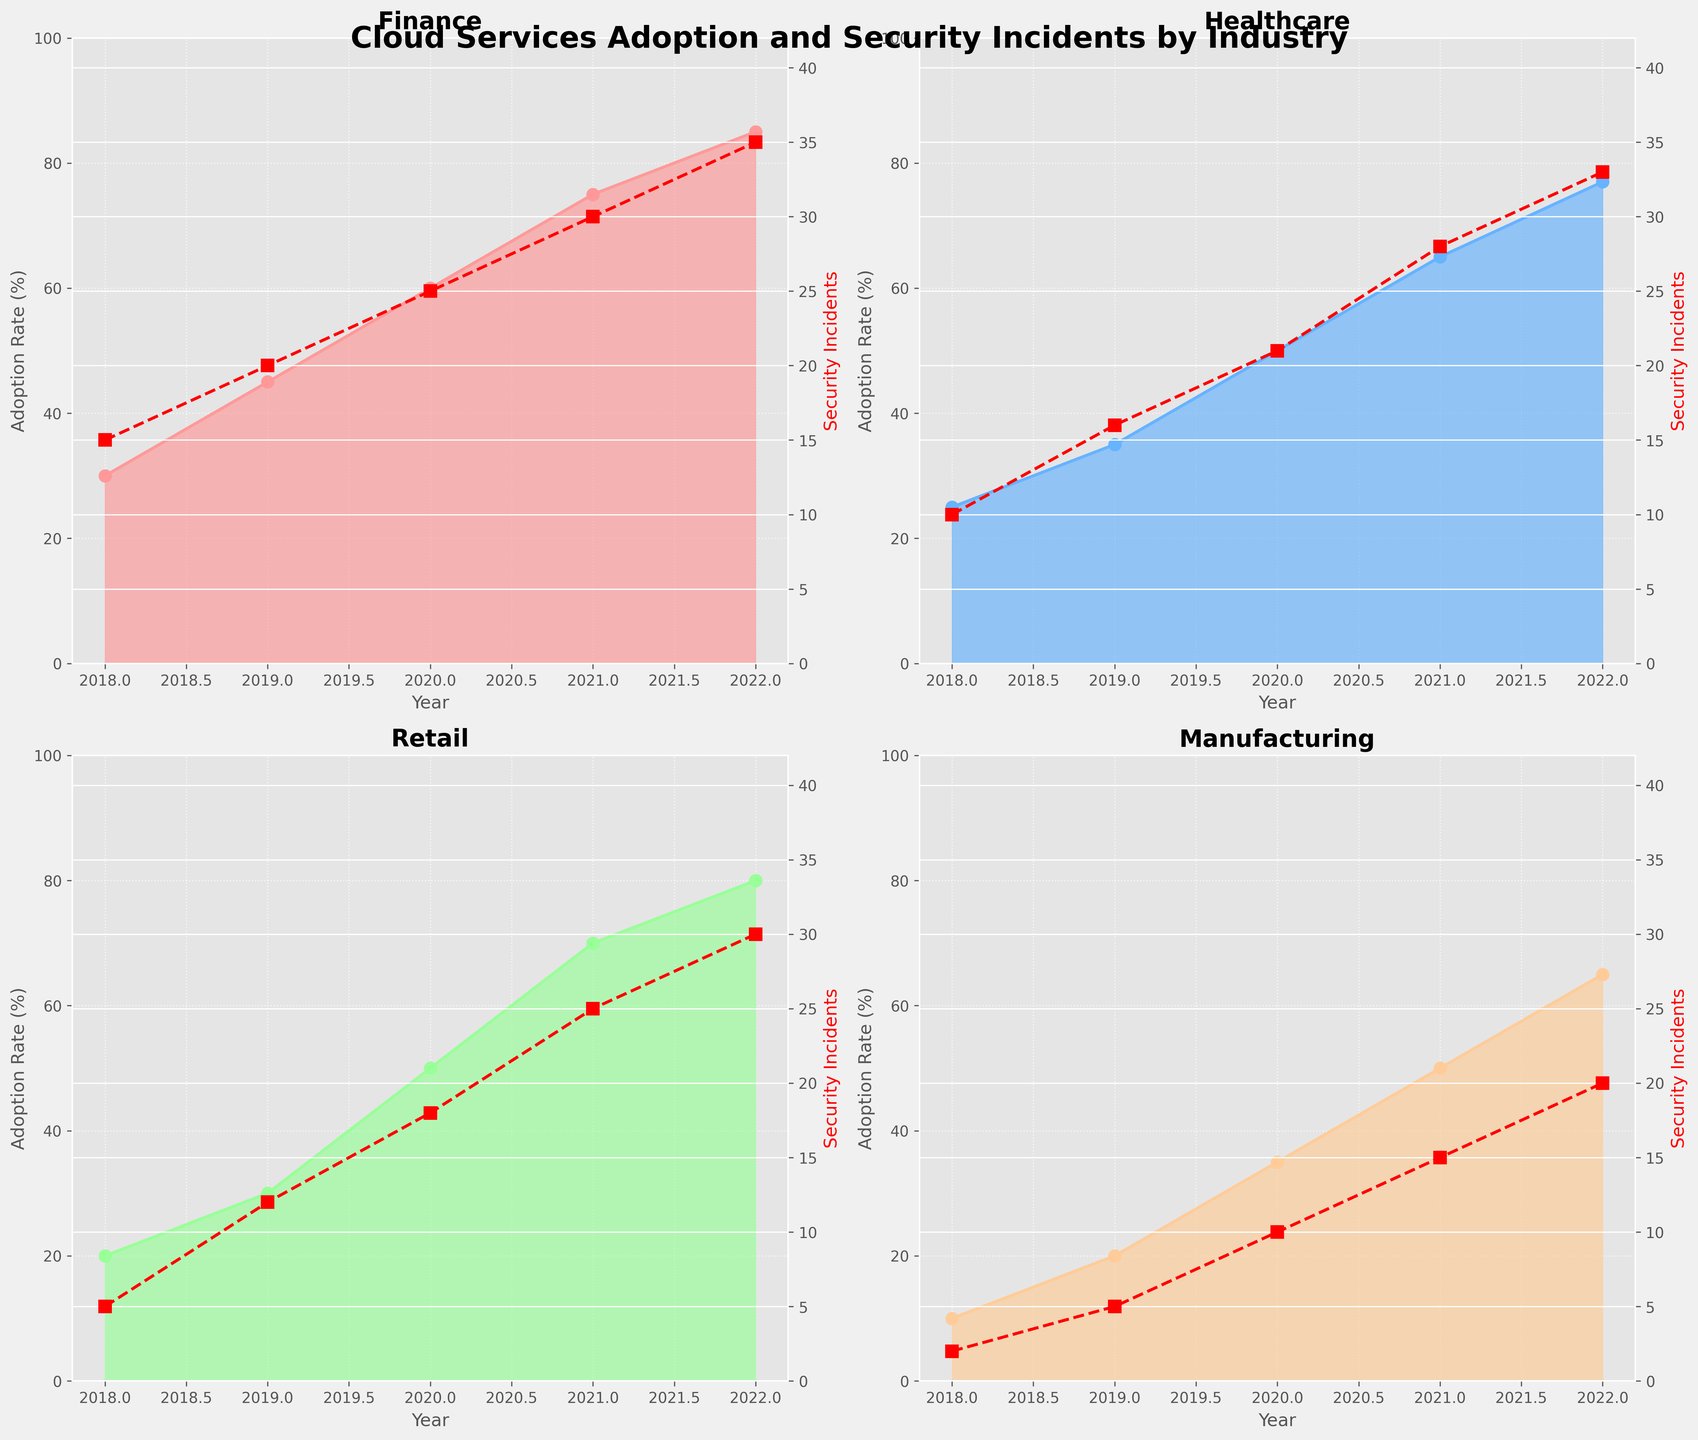How many distinct industries are represented in the figure? There are four distinct subplots, each representing one industry. Therefore, there are four different industries in the figure.
Answer: Four Which industry had the highest cloud adoption rate in 2022? The adoption rates are indicated in each subplot. In 2022, Finance had the highest adoption rate, reaching 85%.
Answer: Finance What is the trend in security incidents in the Healthcare industry between 2018 and 2022? In the Healthcare subplot, the line representing security incidents shows a consistent upward trend from 2018 to 2022. The incidents increased from 10 in 2018 to 33 in 2022.
Answer: Increasing Compare the adoption rates between the Retail and Manufacturing industries in 2020. Which one is higher? In the 2020 data points in the Retail and Manufacturing subplots, Retail has an adoption rate of 50%, while Manufacturing has 35%. Therefore, Retail’s adoption rate is higher.
Answer: Retail What is the difference in the number of security incidents between Finance and Retail in 2021? In the 2021 data points, Finance shows 30 security incidents, whereas Retail shows 25. The difference is 30 - 25 = 5.
Answer: 5 What is the primary color used to fill the area for the Healthcare industry? The primary fill color for Healthcare in its subplot is a shade of blue.
Answer: Blue Identify any year where the Manufacturing industry had the same adoption rate as any other industry. Which industries and years are these? In 2020, both Healthcare and Retail had a 50% adoption rate, similarly to Manufacturing.
Answer: 2020, Healthcare and Retail How many data points are there for each industry's adoption rates? Each subplot displays data from 2018 to 2022, providing 5 data points per industry.
Answer: 5 per industry Which year saw the highest increase in cloud adoption rate in the Finance industry? The Finance subplot shows the largest increase between 2018 and 2019, where the adoption rate went from 30% to 45%, a 15% increase.
Answer: 2019 Compare the increase in security incidents from 2019 to 2022 between the Finance and Healthcare industries. Which industry had a larger increase? From 2019 to 2022, Finance increased from 20 to 35 (an increase of 15 incidents) and Healthcare from 16 to 33 (an increase of 17 incidents). Therefore, Healthcare had a larger increase.
Answer: Healthcare 